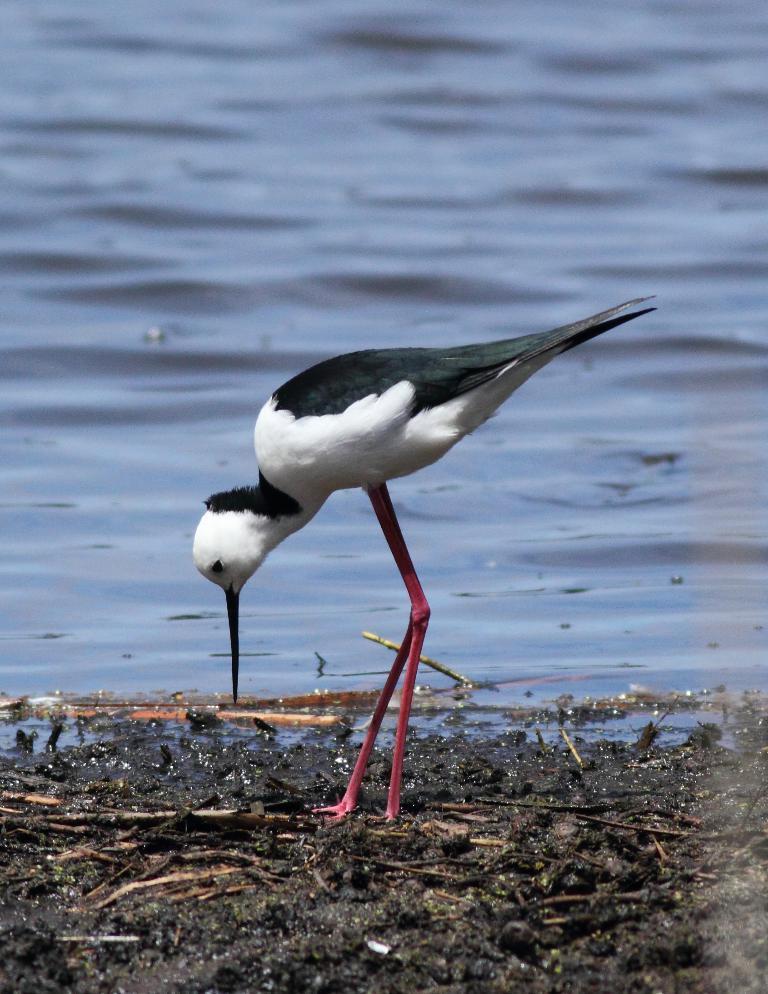In one or two sentences, can you explain what this image depicts? In the picture we can see a bird with a long legs standing on the mud surface and the bird is white in color with some part black and just beside the bird we can see a water. 